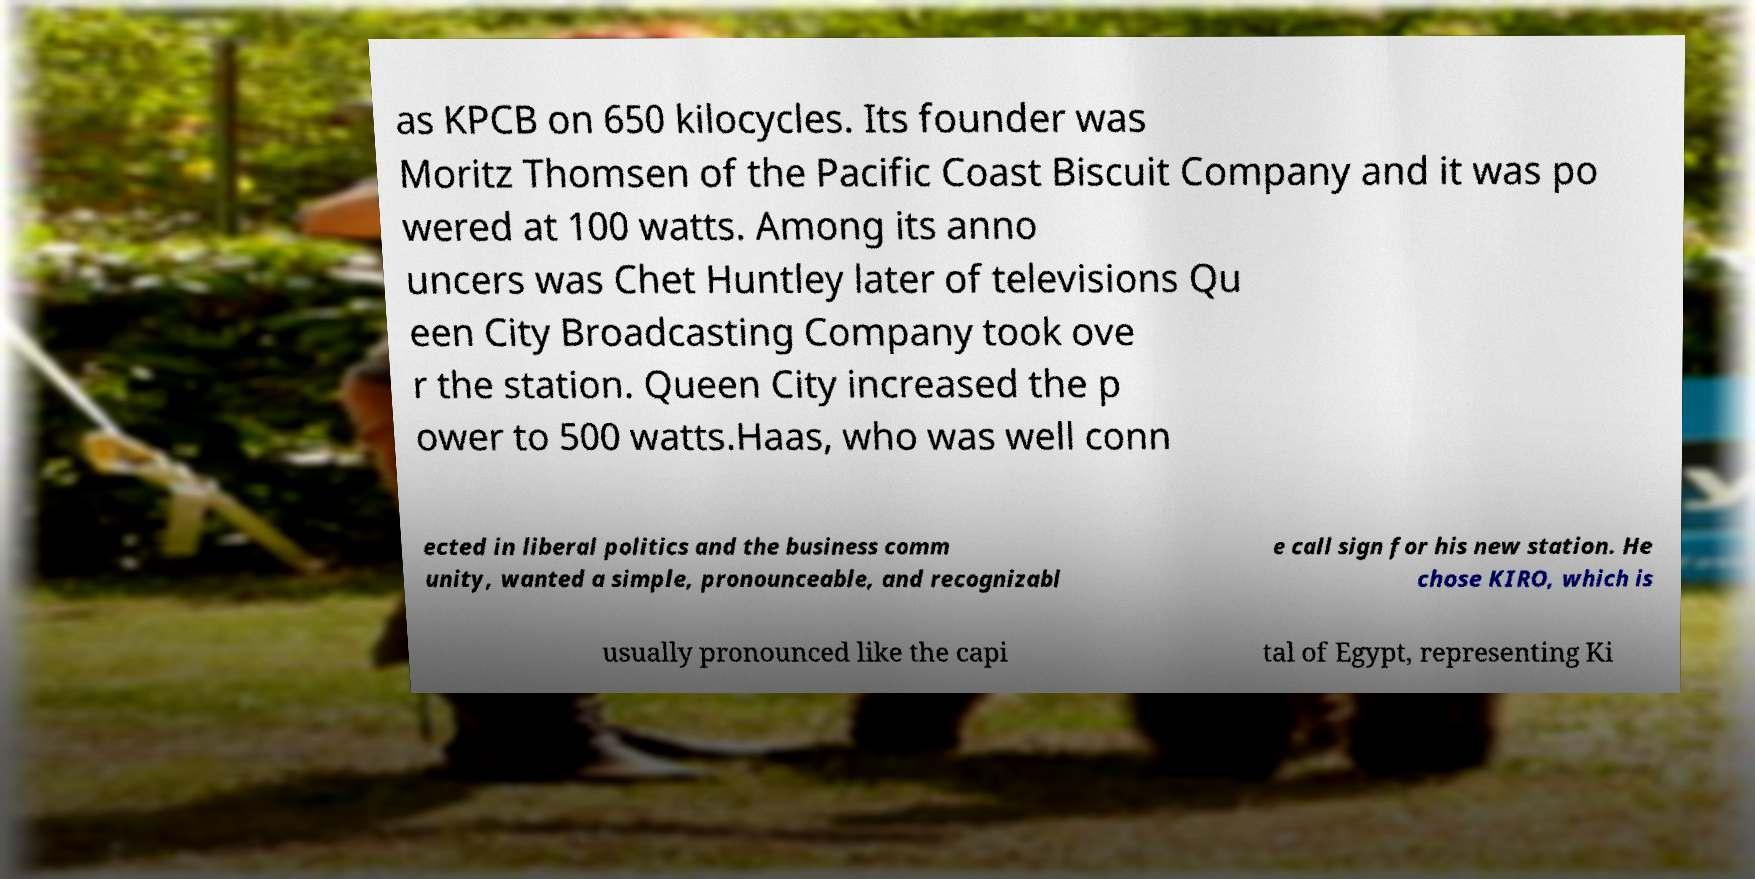There's text embedded in this image that I need extracted. Can you transcribe it verbatim? as KPCB on 650 kilocycles. Its founder was Moritz Thomsen of the Pacific Coast Biscuit Company and it was po wered at 100 watts. Among its anno uncers was Chet Huntley later of televisions Qu een City Broadcasting Company took ove r the station. Queen City increased the p ower to 500 watts.Haas, who was well conn ected in liberal politics and the business comm unity, wanted a simple, pronounceable, and recognizabl e call sign for his new station. He chose KIRO, which is usually pronounced like the capi tal of Egypt, representing Ki 